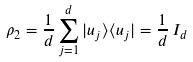<formula> <loc_0><loc_0><loc_500><loc_500>\rho _ { 2 } = \frac { 1 } { d } \sum _ { j = 1 } ^ { d } | u _ { j } \rangle \langle u _ { j } | = \frac { 1 } { d } \, I _ { d }</formula> 